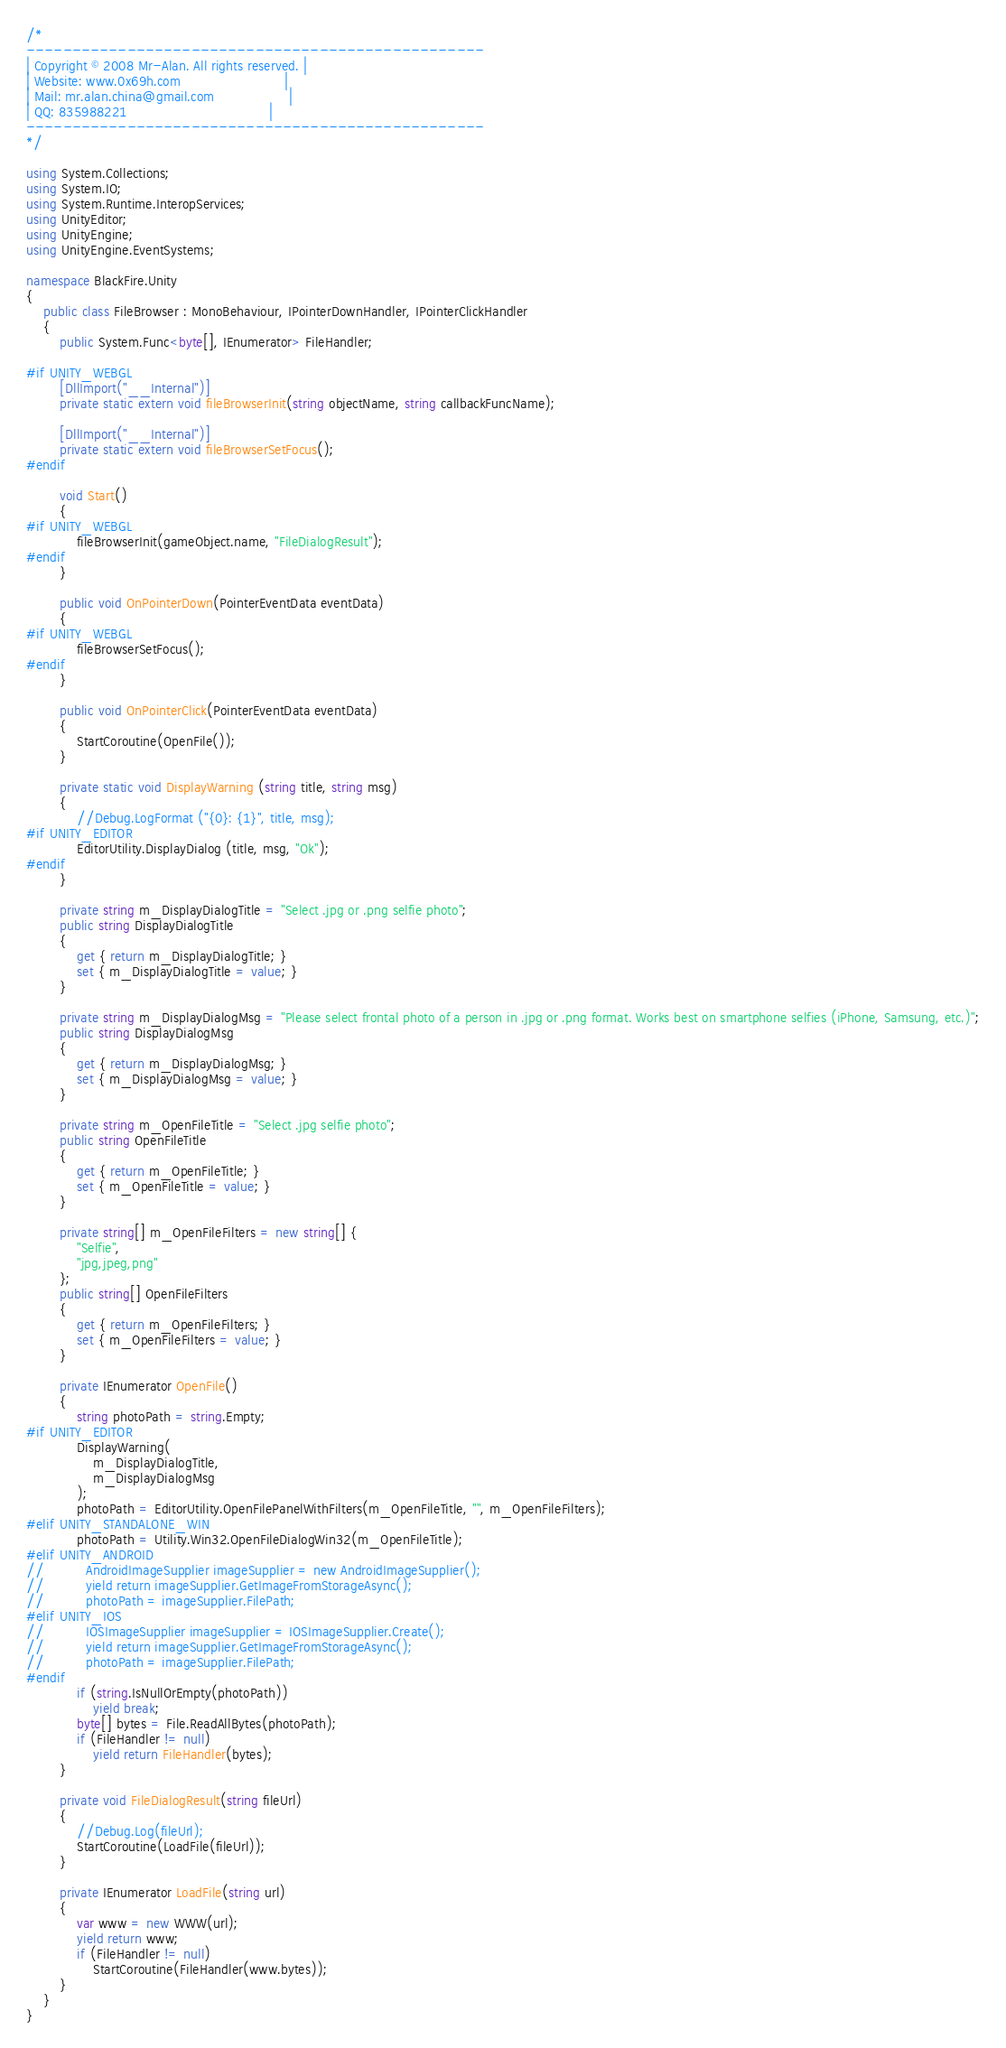Convert code to text. <code><loc_0><loc_0><loc_500><loc_500><_C#_>/*
--------------------------------------------------
| Copyright © 2008 Mr-Alan. All rights reserved. |
| Website: www.0x69h.com                         |
| Mail: mr.alan.china@gmail.com                  |
| QQ: 835988221                                  |
--------------------------------------------------
*/

using System.Collections;
using System.IO;
using System.Runtime.InteropServices;
using UnityEditor;
using UnityEngine;
using UnityEngine.EventSystems;

namespace BlackFire.Unity
{
	public class FileBrowser : MonoBehaviour, IPointerDownHandler, IPointerClickHandler
	{
		public System.Func<byte[], IEnumerator> FileHandler;

#if UNITY_WEBGL
		[DllImport("__Internal")]
		private static extern void fileBrowserInit(string objectName, string callbackFuncName);

		[DllImport("__Internal")]
		private static extern void fileBrowserSetFocus();
#endif

		void Start()
		{
#if UNITY_WEBGL
			fileBrowserInit(gameObject.name, "FileDialogResult");
#endif
		}

		public void OnPointerDown(PointerEventData eventData)
		{
#if UNITY_WEBGL
			fileBrowserSetFocus();
#endif
		}

		public void OnPointerClick(PointerEventData eventData)
		{
			StartCoroutine(OpenFile());
		}

		private static void DisplayWarning (string title, string msg)
		{
			//Debug.LogFormat ("{0}: {1}", title, msg);
#if UNITY_EDITOR
			EditorUtility.DisplayDialog (title, msg, "Ok");
#endif
		}

		private string m_DisplayDialogTitle = "Select .jpg or .png selfie photo";
		public string DisplayDialogTitle
		{
			get { return m_DisplayDialogTitle; }
			set { m_DisplayDialogTitle = value; }
		}
		
		private string m_DisplayDialogMsg = "Please select frontal photo of a person in .jpg or .png format. Works best on smartphone selfies (iPhone, Samsung, etc.)";
		public string DisplayDialogMsg
		{
			get { return m_DisplayDialogMsg; }
			set { m_DisplayDialogMsg = value; }
		}
		
		private string m_OpenFileTitle = "Select .jpg selfie photo";
		public string OpenFileTitle
		{
			get { return m_OpenFileTitle; }
			set { m_OpenFileTitle = value; }
		}

		private string[] m_OpenFileFilters = new string[] {
			"Selfie",
			"jpg,jpeg,png"
		};
		public string[] OpenFileFilters
		{
			get { return m_OpenFileFilters; }
			set { m_OpenFileFilters = value; }
		}
		
		private IEnumerator OpenFile()
		{
			string photoPath = string.Empty;
#if UNITY_EDITOR
			DisplayWarning(
				m_DisplayDialogTitle,
				m_DisplayDialogMsg
			);
			photoPath = EditorUtility.OpenFilePanelWithFilters(m_OpenFileTitle, "", m_OpenFileFilters);
#elif UNITY_STANDALONE_WIN
			photoPath = Utility.Win32.OpenFileDialogWin32(m_OpenFileTitle);
#elif UNITY_ANDROID
//			AndroidImageSupplier imageSupplier = new AndroidImageSupplier();
//			yield return imageSupplier.GetImageFromStorageAsync();
//			photoPath = imageSupplier.FilePath;
#elif UNITY_IOS
//			IOSImageSupplier imageSupplier = IOSImageSupplier.Create();
//			yield return imageSupplier.GetImageFromStorageAsync();
//			photoPath = imageSupplier.FilePath;
#endif
			if (string.IsNullOrEmpty(photoPath))
				yield break;
			byte[] bytes = File.ReadAllBytes(photoPath);
			if (FileHandler != null)
				yield return FileHandler(bytes);
		}

		private void FileDialogResult(string fileUrl)
		{
			//Debug.Log(fileUrl);
			StartCoroutine(LoadFile(fileUrl));
		}

		private IEnumerator LoadFile(string url)
		{
			var www = new WWW(url);
			yield return www;
			if (FileHandler != null)
				StartCoroutine(FileHandler(www.bytes));
		}
	}
}</code> 